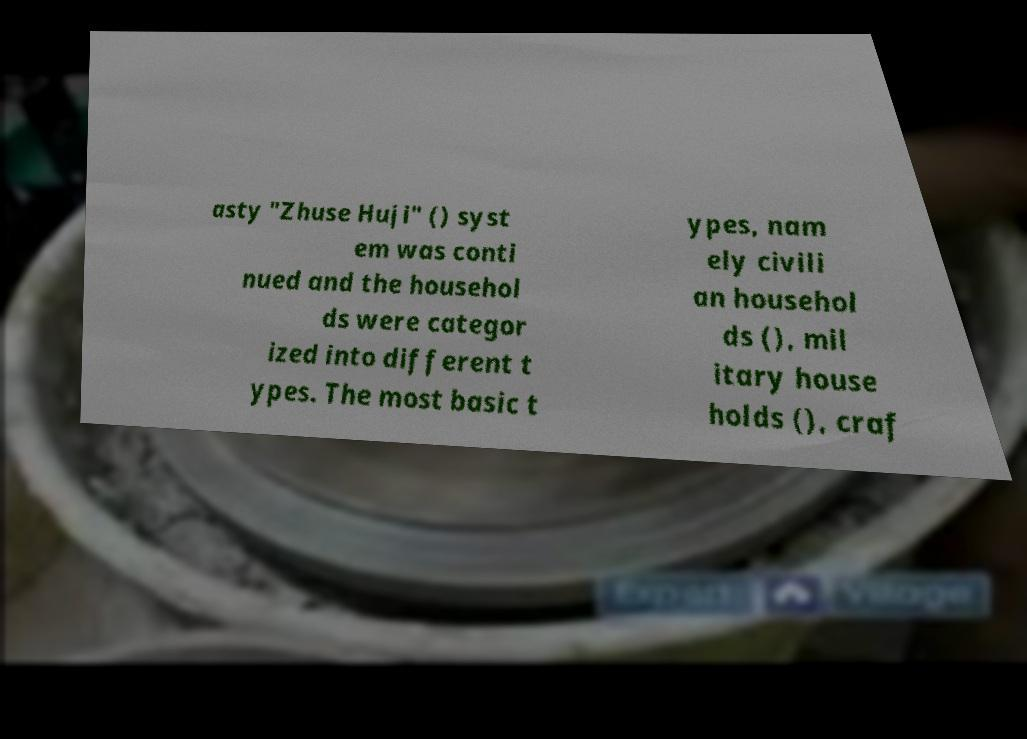There's text embedded in this image that I need extracted. Can you transcribe it verbatim? asty "Zhuse Huji" () syst em was conti nued and the househol ds were categor ized into different t ypes. The most basic t ypes, nam ely civili an househol ds (), mil itary house holds (), craf 